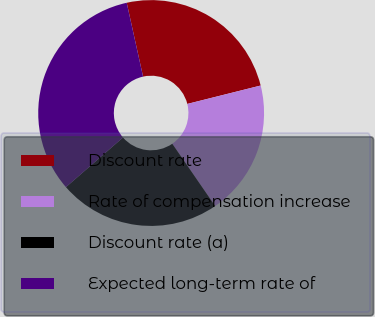<chart> <loc_0><loc_0><loc_500><loc_500><pie_chart><fcel>Discount rate<fcel>Rate of compensation increase<fcel>Discount rate (a)<fcel>Expected long-term rate of<nl><fcel>24.56%<fcel>19.32%<fcel>23.2%<fcel>32.93%<nl></chart> 